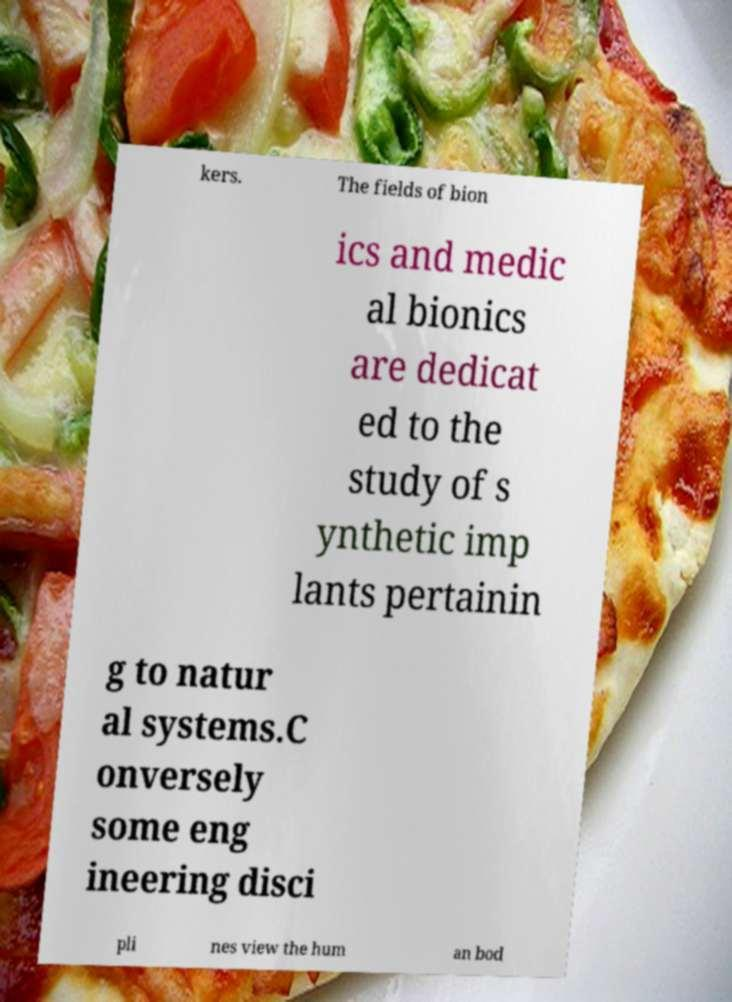Could you assist in decoding the text presented in this image and type it out clearly? kers. The fields of bion ics and medic al bionics are dedicat ed to the study of s ynthetic imp lants pertainin g to natur al systems.C onversely some eng ineering disci pli nes view the hum an bod 